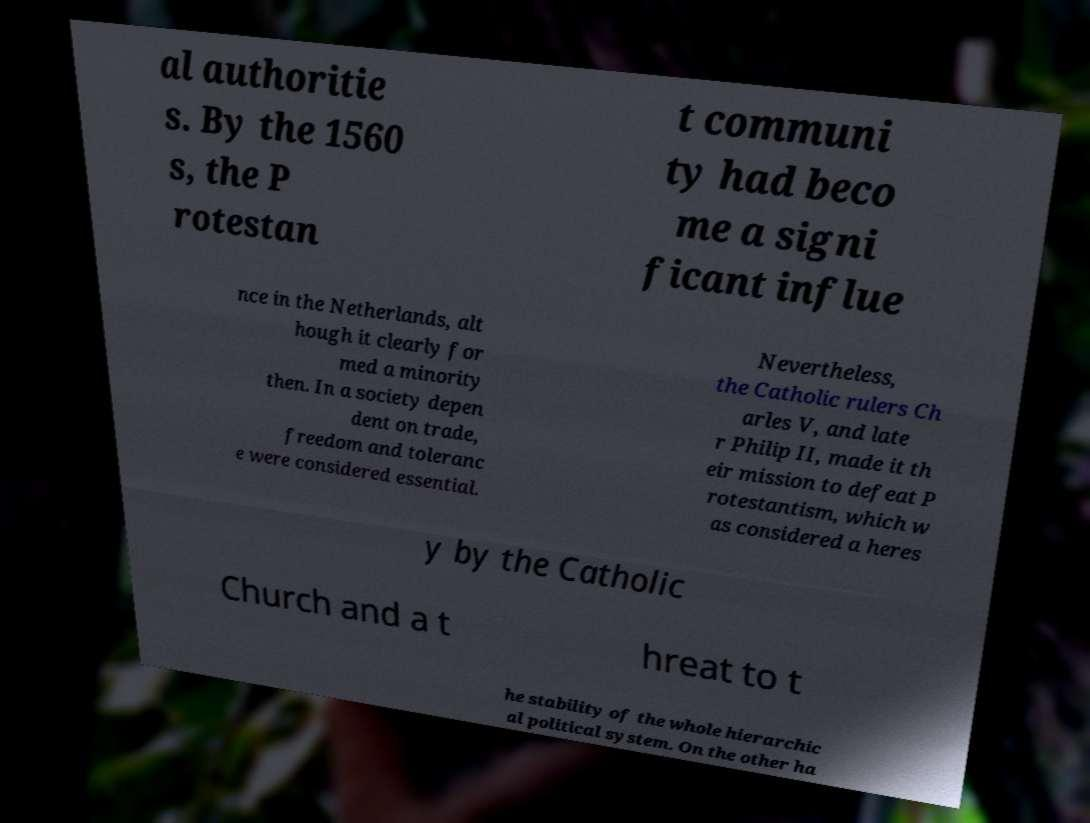Could you extract and type out the text from this image? al authoritie s. By the 1560 s, the P rotestan t communi ty had beco me a signi ficant influe nce in the Netherlands, alt hough it clearly for med a minority then. In a society depen dent on trade, freedom and toleranc e were considered essential. Nevertheless, the Catholic rulers Ch arles V, and late r Philip II, made it th eir mission to defeat P rotestantism, which w as considered a heres y by the Catholic Church and a t hreat to t he stability of the whole hierarchic al political system. On the other ha 